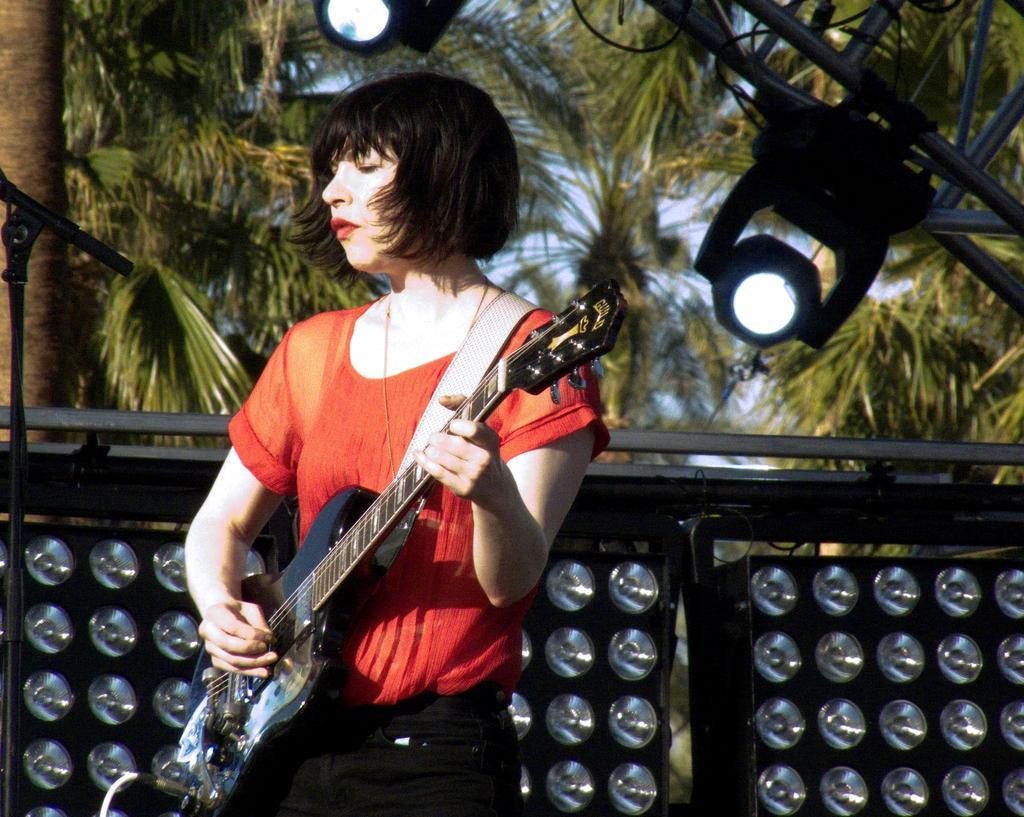Can you describe this image briefly? In this image I can see a woman wearing red color t-shirt and playing the guitar. In the background I can see some lights and trees. 